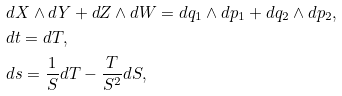Convert formula to latex. <formula><loc_0><loc_0><loc_500><loc_500>& d X \wedge d Y + d Z \wedge d W = d q _ { 1 } \wedge d p _ { 1 } + d q _ { 2 } \wedge d p _ { 2 } , \\ & d t = d T , \\ & d s = \frac { 1 } { S } d T - \frac { T } { S ^ { 2 } } d S ,</formula> 